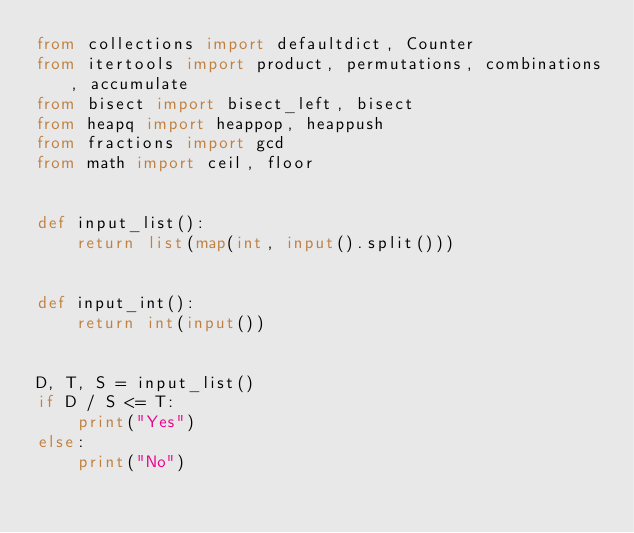<code> <loc_0><loc_0><loc_500><loc_500><_Python_>from collections import defaultdict, Counter
from itertools import product, permutations, combinations, accumulate
from bisect import bisect_left, bisect
from heapq import heappop, heappush
from fractions import gcd
from math import ceil, floor


def input_list():
    return list(map(int, input().split()))


def input_int():
    return int(input())


D, T, S = input_list()
if D / S <= T:
    print("Yes")
else:
    print("No")
</code> 